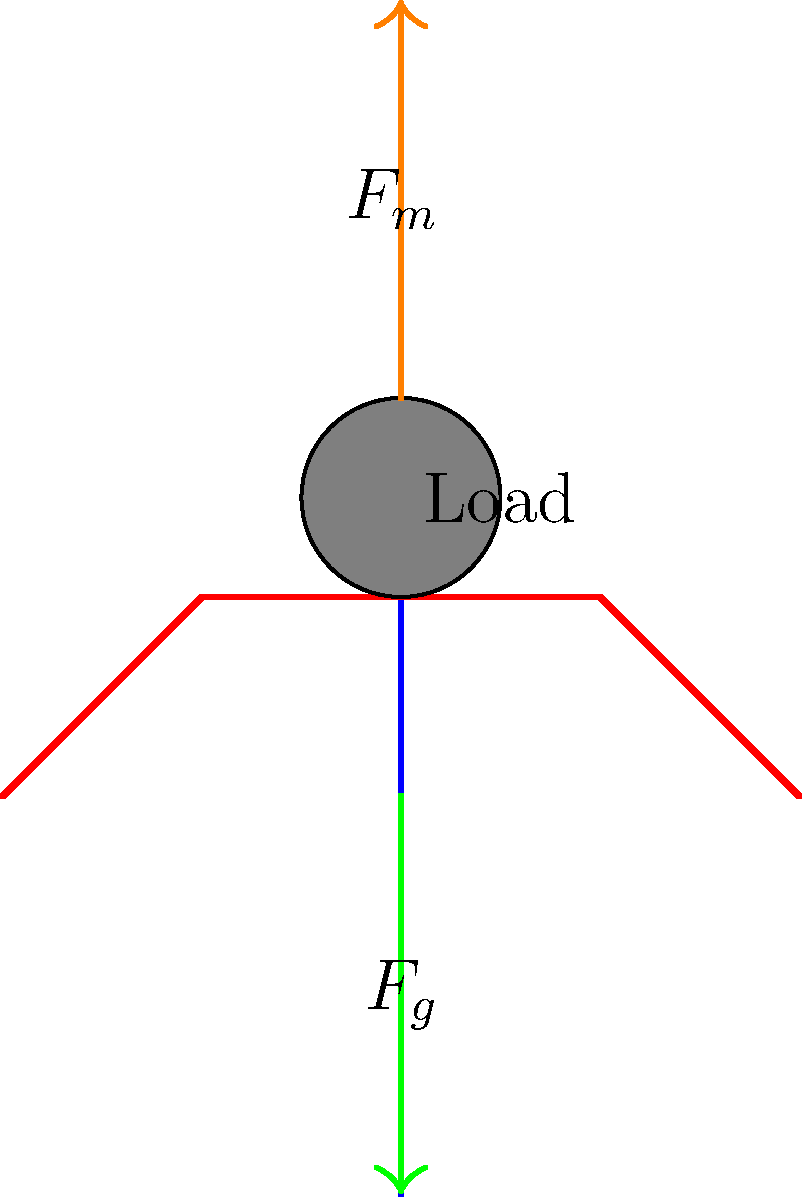When lifting a heavy object, the forces acting on a person's spine can be significant. Consider a situation where an immigrant worker is learning proper lifting techniques. If the combined weight of the worker's upper body and the load is 500 N, and the muscular force exerted by the back muscles is 2000 N, what is the compressive force on the lower spine? To solve this problem, we'll follow these steps:

1. Identify the forces acting on the spine:
   - $F_g$: Gravitational force (weight of upper body + load)
   - $F_m$: Muscular force exerted by back muscles
   - $F_c$: Compressive force on the lower spine (what we're solving for)

2. Understand that the compressive force is the sum of the downward forces:
   $F_c = F_g + F_m$

3. Substitute the given values:
   $F_g = 500 \text{ N}$ (combined weight of upper body and load)
   $F_m = 2000 \text{ N}$ (muscular force)

4. Calculate the compressive force:
   $F_c = F_g + F_m = 500 \text{ N} + 2000 \text{ N} = 2500 \text{ N}$

This high compressive force demonstrates the importance of proper lifting techniques to minimize strain on the lower back, which is crucial information for immigrant workers in physically demanding jobs.
Answer: 2500 N 